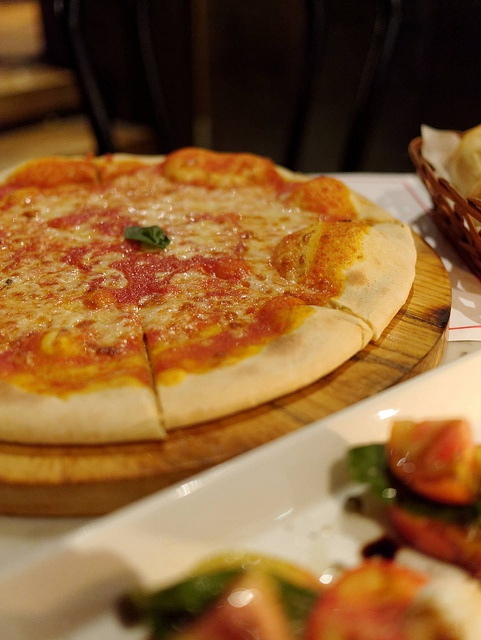Describe the objects in this image and their specific colors. I can see pizza in maroon, red, tan, and brown tones, chair in maroon, black, red, and olive tones, and chair in maroon and black tones in this image. 